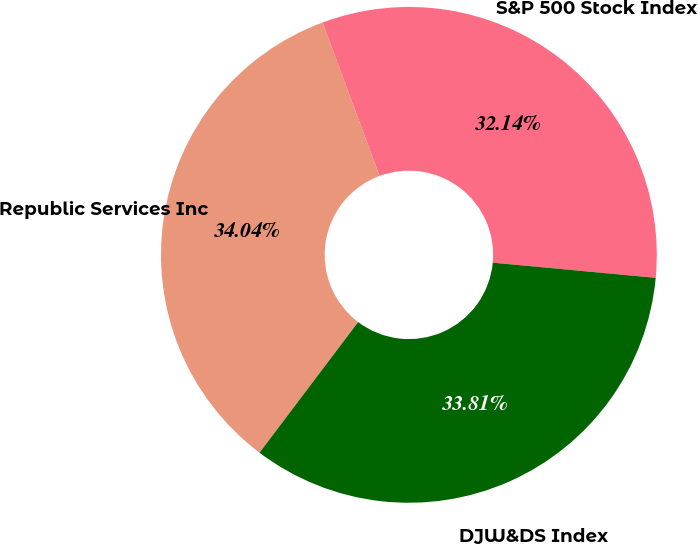<chart> <loc_0><loc_0><loc_500><loc_500><pie_chart><fcel>Republic Services Inc<fcel>S&P 500 Stock Index<fcel>DJW&DS Index<nl><fcel>34.04%<fcel>32.14%<fcel>33.81%<nl></chart> 